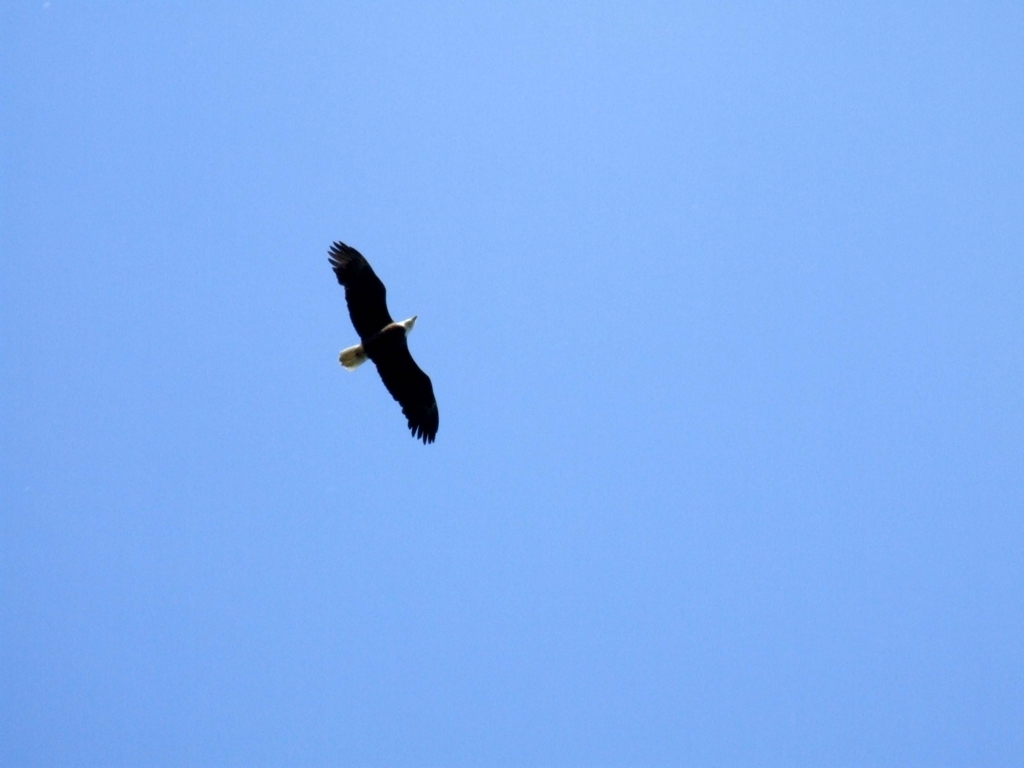Are there any quality issues with this image? The image is generally clear with a bald eagle captured in flight against a plain blue sky. However, the quality could be improved by enhancing the contrast and sharpness to bring out more details in the eagle's feathers. Additionally, the subject is quite small within the frame; closer cropping or zooming in at the time of capture could create a more impactful composition that showcases the majesty of the bird. 